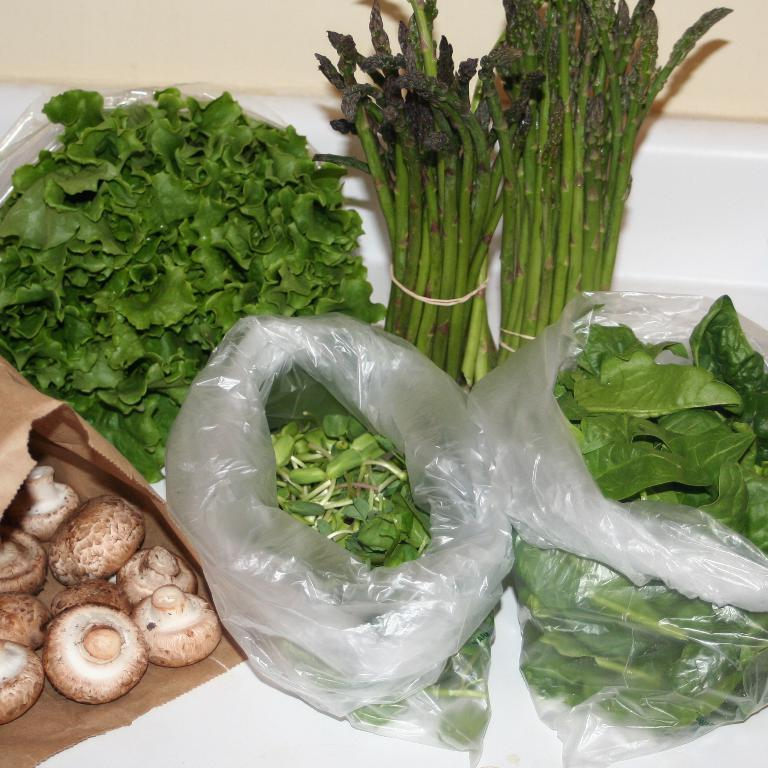What type of food items can be seen on the white surface in the image? There are vegetables on a white surface in the image. How are the leafy vegetables packaged? There are two polythene covers containing leafy vegetables. What type of vegetable is in the brown packet on the left side? There are mushrooms in a brown packet on the left side. How many men are visible in the image? There are no men visible in the image; it only features vegetables and packaging. What type of growth is being protected by the scarecrow in the image? There is no scarecrow present in the image. 